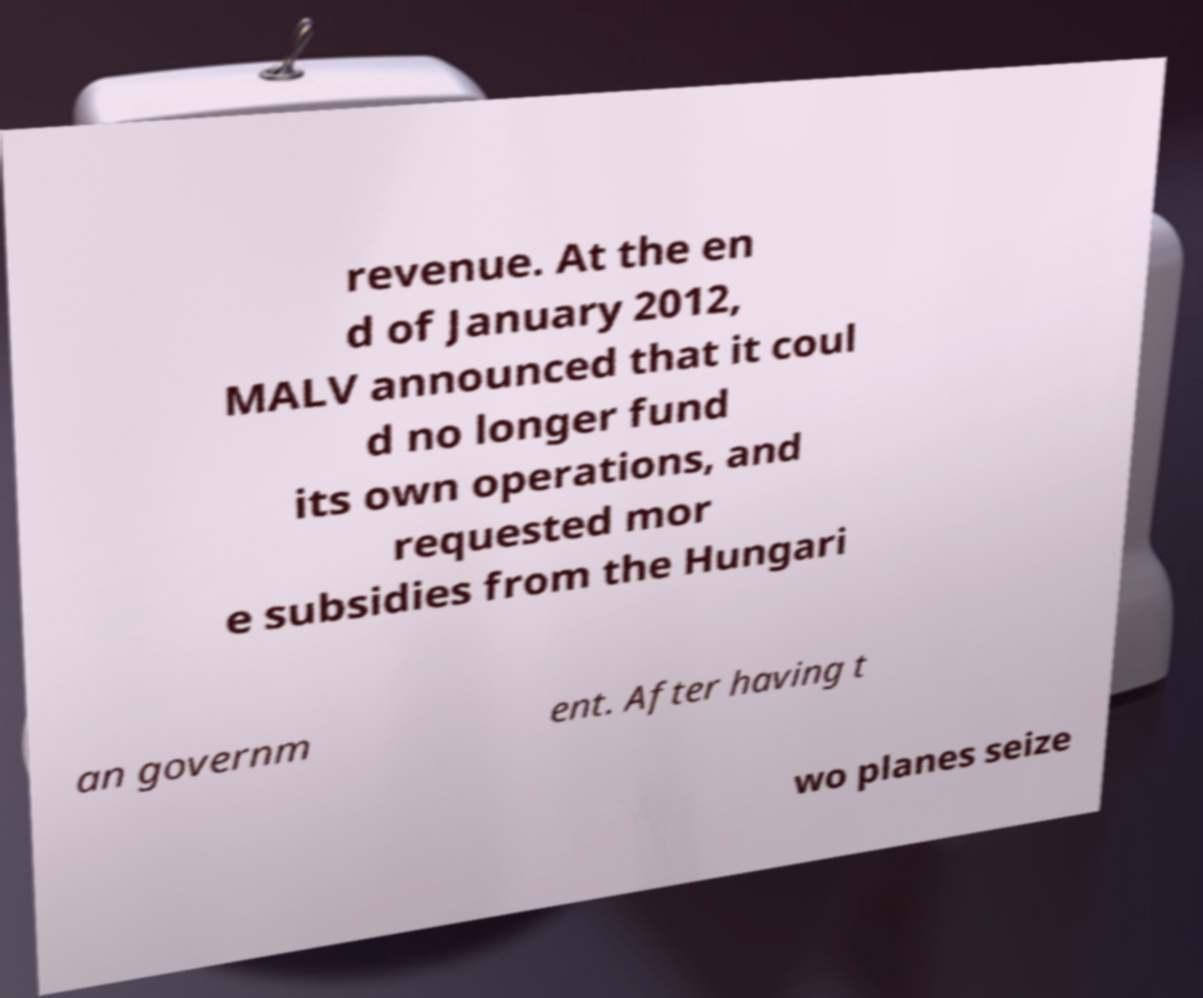Please read and relay the text visible in this image. What does it say? revenue. At the en d of January 2012, MALV announced that it coul d no longer fund its own operations, and requested mor e subsidies from the Hungari an governm ent. After having t wo planes seize 